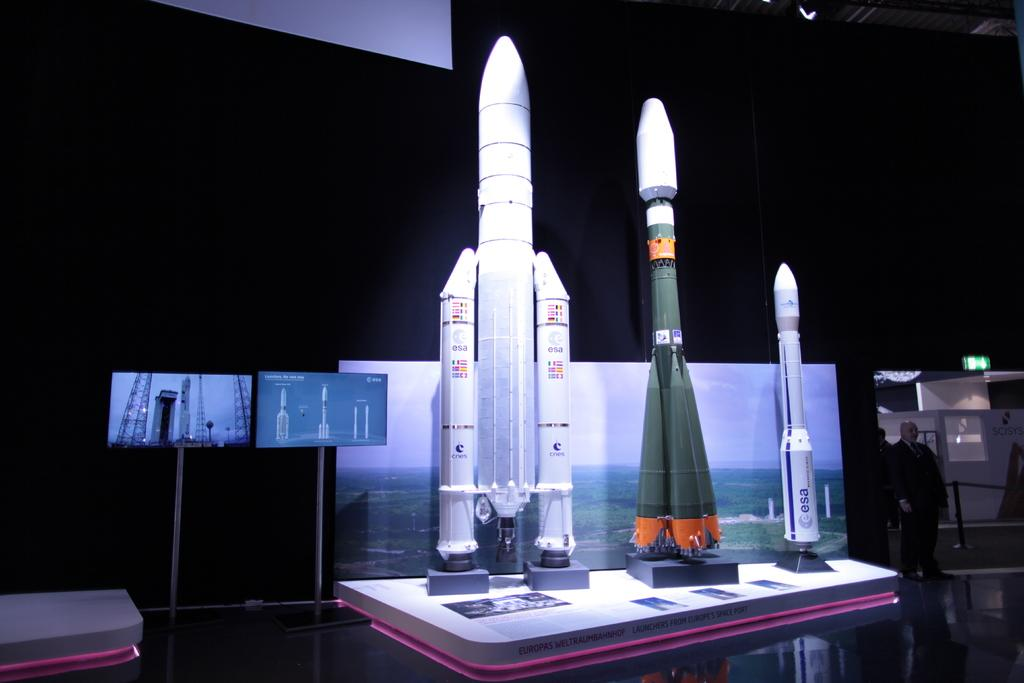What objects are on the table in the image? There are models of missiles and rockets on a table. What other items related to missiles and rockets can be seen in the image? There are pictures of missiles and rockets beside the table. Can you describe the people in the image? People are standing in the far distance. What type of word is written on the side of the rocket in the image? There are no words written on the side of the rocket in the image; it is a model and not a real rocket. Can you see any kittens in the image? There are no kittens present in the image. 